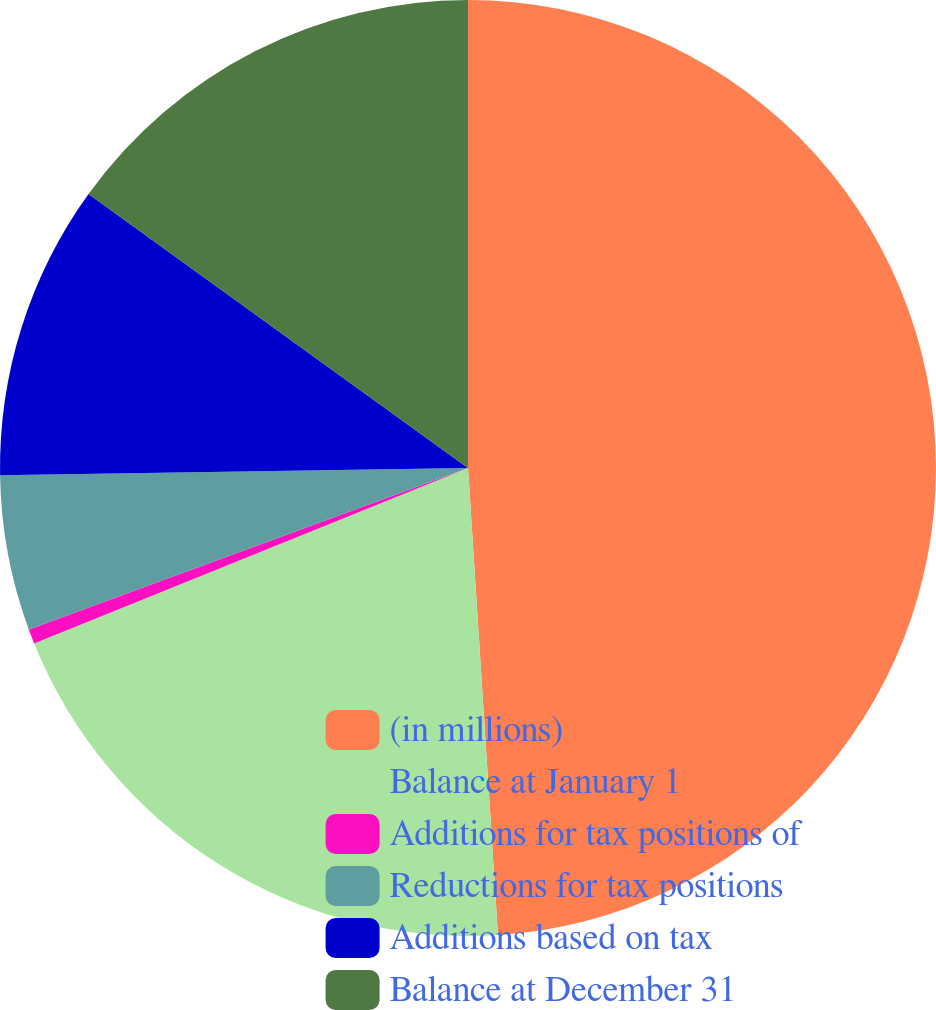Convert chart. <chart><loc_0><loc_0><loc_500><loc_500><pie_chart><fcel>(in millions)<fcel>Balance at January 1<fcel>Additions for tax positions of<fcel>Reductions for tax positions<fcel>Additions based on tax<fcel>Balance at December 31<nl><fcel>48.98%<fcel>19.9%<fcel>0.51%<fcel>5.36%<fcel>10.2%<fcel>15.05%<nl></chart> 